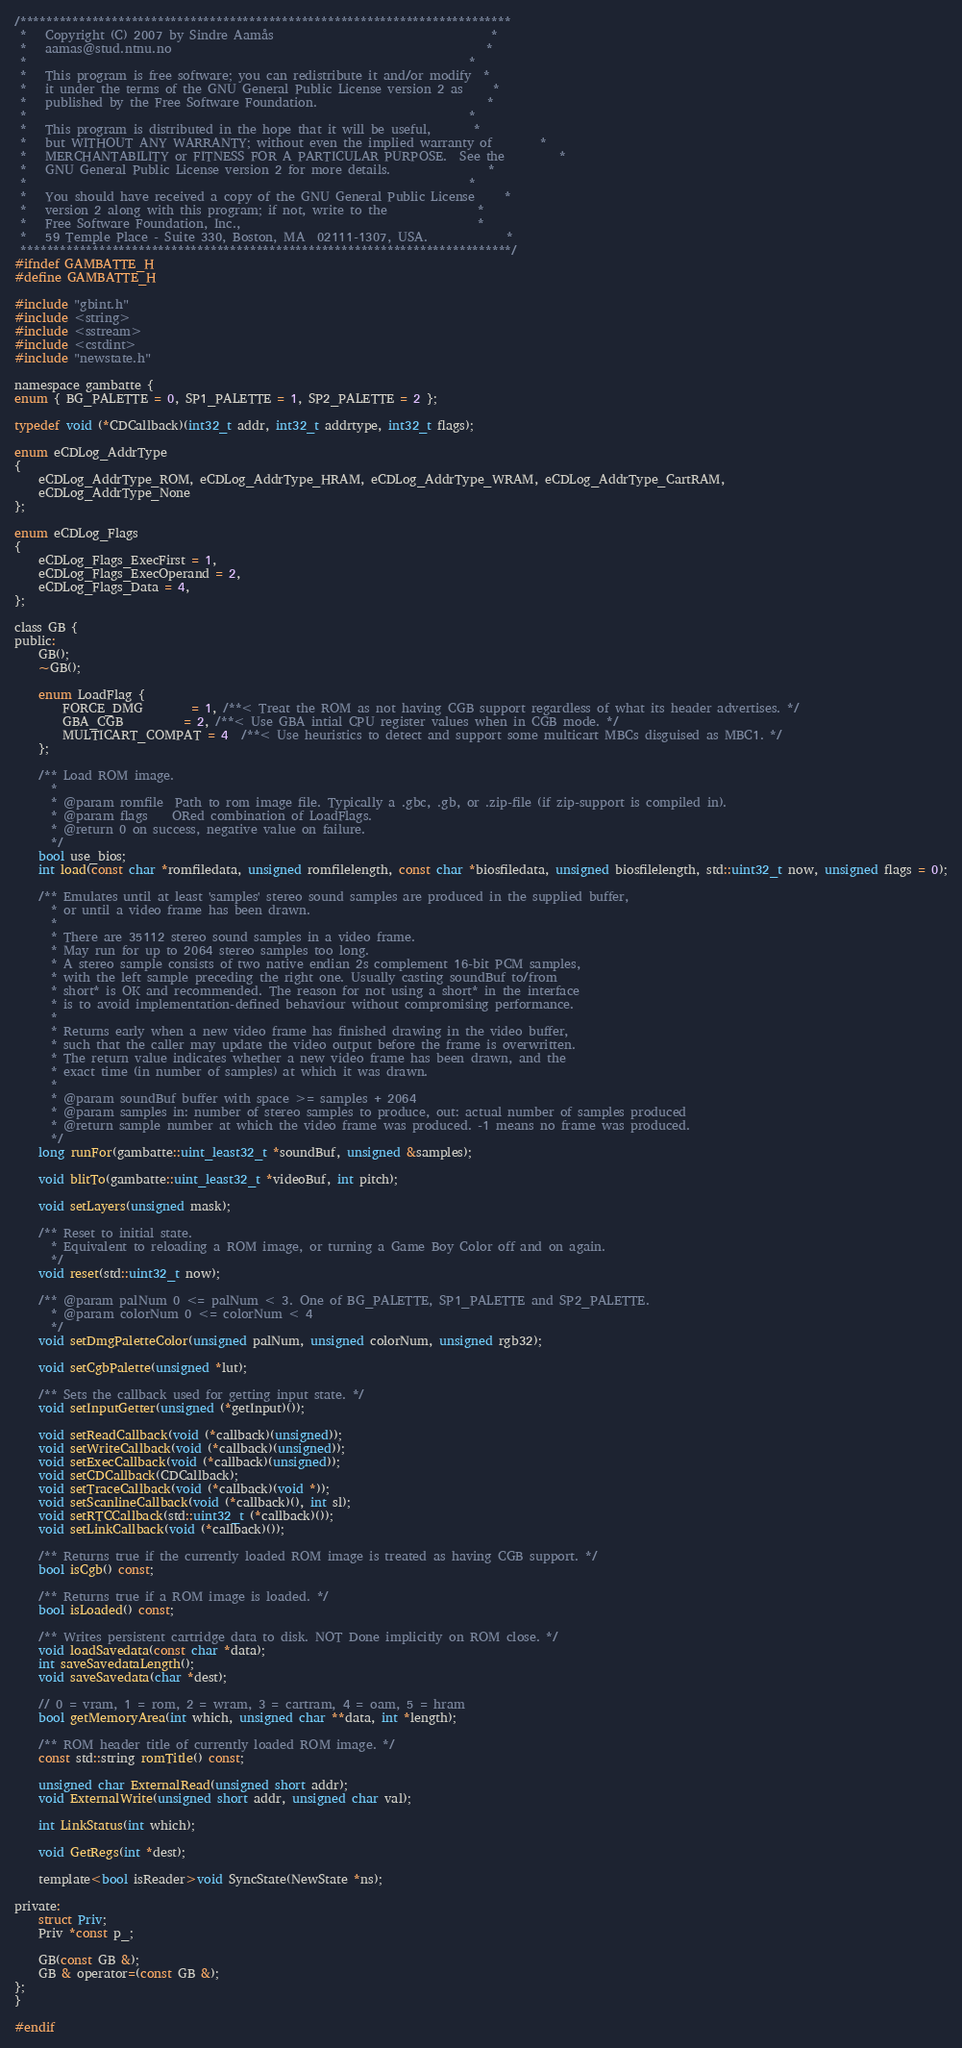<code> <loc_0><loc_0><loc_500><loc_500><_C_>/***************************************************************************
 *   Copyright (C) 2007 by Sindre Aamås                                    *
 *   aamas@stud.ntnu.no                                                    *
 *                                                                         *
 *   This program is free software; you can redistribute it and/or modify  *
 *   it under the terms of the GNU General Public License version 2 as     *
 *   published by the Free Software Foundation.                            *
 *                                                                         *
 *   This program is distributed in the hope that it will be useful,       *
 *   but WITHOUT ANY WARRANTY; without even the implied warranty of        *
 *   MERCHANTABILITY or FITNESS FOR A PARTICULAR PURPOSE.  See the         *
 *   GNU General Public License version 2 for more details.                *
 *                                                                         *
 *   You should have received a copy of the GNU General Public License     *
 *   version 2 along with this program; if not, write to the               *
 *   Free Software Foundation, Inc.,                                       *
 *   59 Temple Place - Suite 330, Boston, MA  02111-1307, USA.             *
 ***************************************************************************/
#ifndef GAMBATTE_H
#define GAMBATTE_H

#include "gbint.h"
#include <string>
#include <sstream>
#include <cstdint>
#include "newstate.h"

namespace gambatte {
enum { BG_PALETTE = 0, SP1_PALETTE = 1, SP2_PALETTE = 2 };

typedef void (*CDCallback)(int32_t addr, int32_t addrtype, int32_t flags);

enum eCDLog_AddrType
{
	eCDLog_AddrType_ROM, eCDLog_AddrType_HRAM, eCDLog_AddrType_WRAM, eCDLog_AddrType_CartRAM,
	eCDLog_AddrType_None
};

enum eCDLog_Flags
{
	eCDLog_Flags_ExecFirst = 1,
	eCDLog_Flags_ExecOperand = 2,
	eCDLog_Flags_Data = 4,
};

class GB {
public:
	GB();
	~GB();
	
	enum LoadFlag {
		FORCE_DMG        = 1, /**< Treat the ROM as not having CGB support regardless of what its header advertises. */
		GBA_CGB          = 2, /**< Use GBA intial CPU register values when in CGB mode. */
		MULTICART_COMPAT = 4  /**< Use heuristics to detect and support some multicart MBCs disguised as MBC1. */
	};
	
	/** Load ROM image.
	  *
	  * @param romfile  Path to rom image file. Typically a .gbc, .gb, or .zip-file (if zip-support is compiled in).
	  * @param flags    ORed combination of LoadFlags.
	  * @return 0 on success, negative value on failure.
	  */
	bool use_bios;
	int load(const char *romfiledata, unsigned romfilelength, const char *biosfiledata, unsigned biosfilelength, std::uint32_t now, unsigned flags = 0);
	
	/** Emulates until at least 'samples' stereo sound samples are produced in the supplied buffer,
	  * or until a video frame has been drawn.
	  *
	  * There are 35112 stereo sound samples in a video frame.
	  * May run for up to 2064 stereo samples too long.
	  * A stereo sample consists of two native endian 2s complement 16-bit PCM samples,
	  * with the left sample preceding the right one. Usually casting soundBuf to/from
	  * short* is OK and recommended. The reason for not using a short* in the interface
	  * is to avoid implementation-defined behaviour without compromising performance.
	  *
	  * Returns early when a new video frame has finished drawing in the video buffer,
	  * such that the caller may update the video output before the frame is overwritten.
	  * The return value indicates whether a new video frame has been drawn, and the
	  * exact time (in number of samples) at which it was drawn.
	  *
	  * @param soundBuf buffer with space >= samples + 2064
	  * @param samples in: number of stereo samples to produce, out: actual number of samples produced
	  * @return sample number at which the video frame was produced. -1 means no frame was produced.
	  */
	long runFor(gambatte::uint_least32_t *soundBuf, unsigned &samples);

	void blitTo(gambatte::uint_least32_t *videoBuf, int pitch);

	void setLayers(unsigned mask);

	/** Reset to initial state.
	  * Equivalent to reloading a ROM image, or turning a Game Boy Color off and on again.
	  */
	void reset(std::uint32_t now);
	
	/** @param palNum 0 <= palNum < 3. One of BG_PALETTE, SP1_PALETTE and SP2_PALETTE.
	  * @param colorNum 0 <= colorNum < 4
	  */
	void setDmgPaletteColor(unsigned palNum, unsigned colorNum, unsigned rgb32);
	
	void setCgbPalette(unsigned *lut);

	/** Sets the callback used for getting input state. */
	void setInputGetter(unsigned (*getInput)());
	
	void setReadCallback(void (*callback)(unsigned));
	void setWriteCallback(void (*callback)(unsigned));
	void setExecCallback(void (*callback)(unsigned));
	void setCDCallback(CDCallback);
	void setTraceCallback(void (*callback)(void *));
	void setScanlineCallback(void (*callback)(), int sl);
	void setRTCCallback(std::uint32_t (*callback)());
	void setLinkCallback(void (*callback)());

	/** Returns true if the currently loaded ROM image is treated as having CGB support. */
	bool isCgb() const;
	
	/** Returns true if a ROM image is loaded. */
	bool isLoaded() const;

	/** Writes persistent cartridge data to disk. NOT Done implicitly on ROM close. */
	void loadSavedata(const char *data);
	int saveSavedataLength();
	void saveSavedata(char *dest);
	
	// 0 = vram, 1 = rom, 2 = wram, 3 = cartram, 4 = oam, 5 = hram
	bool getMemoryArea(int which, unsigned char **data, int *length);
	
	/** ROM header title of currently loaded ROM image. */
	const std::string romTitle() const;

	unsigned char ExternalRead(unsigned short addr);
	void ExternalWrite(unsigned short addr, unsigned char val);

	int LinkStatus(int which);

	void GetRegs(int *dest);

	template<bool isReader>void SyncState(NewState *ns);

private:
	struct Priv;
	Priv *const p_;

	GB(const GB &);
	GB & operator=(const GB &);
};
}

#endif
</code> 